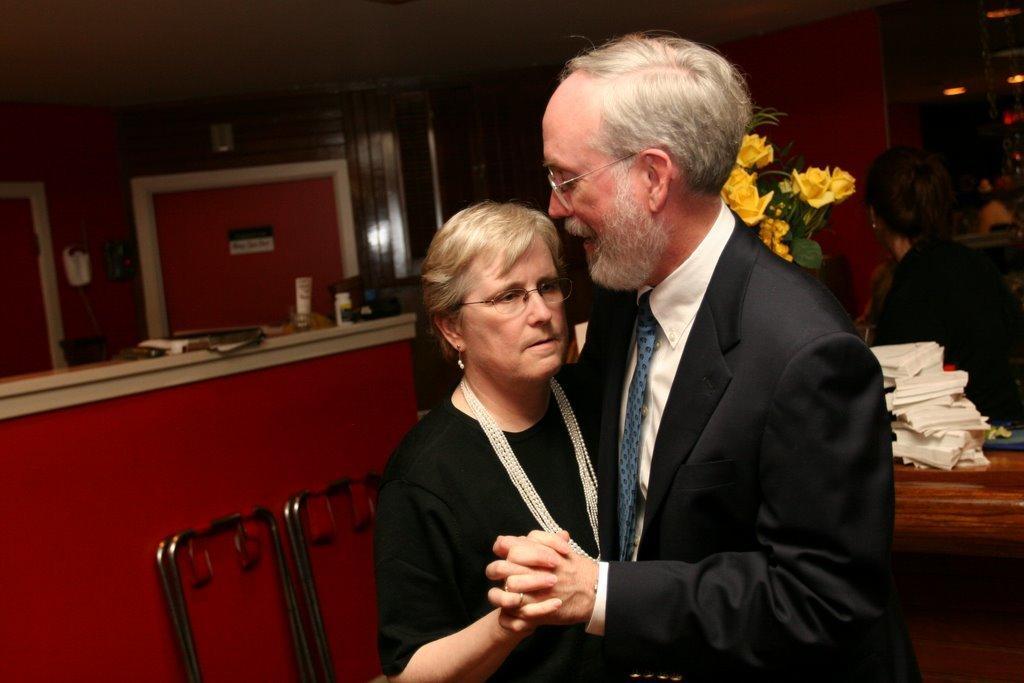How would you summarize this image in a sentence or two? This image consists of two persons. One is man, another one is woman. There are flowers behind them. There are tissues on the right side. 